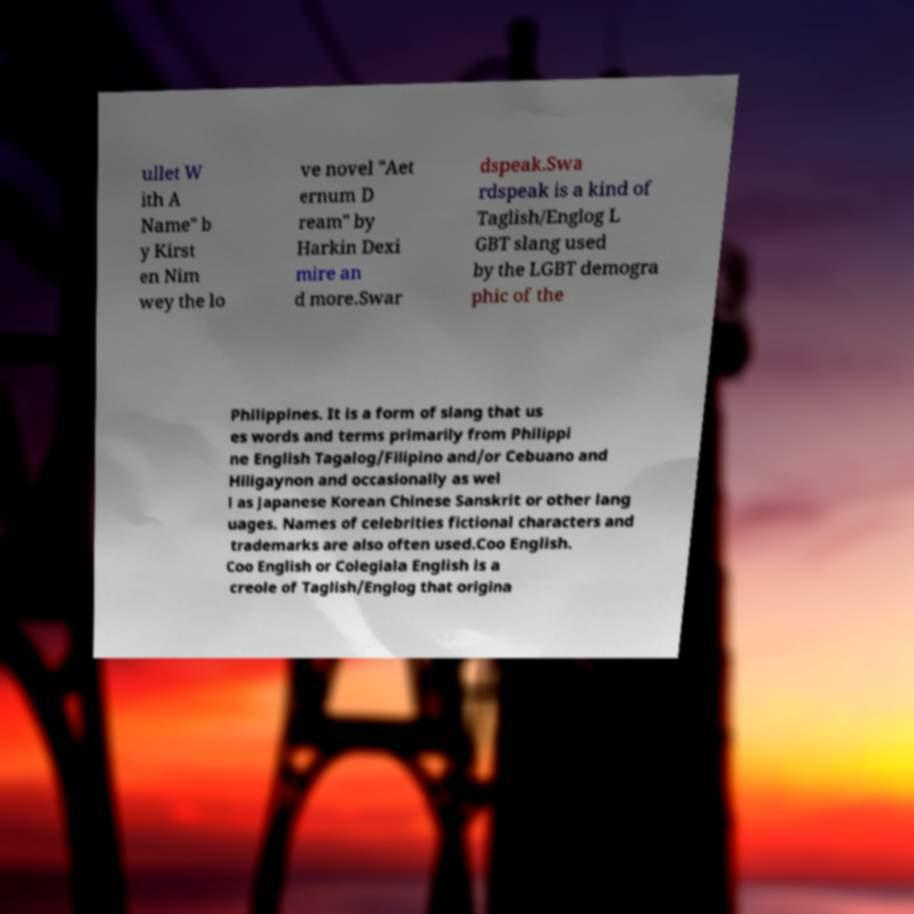I need the written content from this picture converted into text. Can you do that? ullet W ith A Name" b y Kirst en Nim wey the lo ve novel "Aet ernum D ream" by Harkin Dexi mire an d more.Swar dspeak.Swa rdspeak is a kind of Taglish/Englog L GBT slang used by the LGBT demogra phic of the Philippines. It is a form of slang that us es words and terms primarily from Philippi ne English Tagalog/Filipino and/or Cebuano and Hiligaynon and occasionally as wel l as Japanese Korean Chinese Sanskrit or other lang uages. Names of celebrities fictional characters and trademarks are also often used.Coo English. Coo English or Colegiala English is a creole of Taglish/Englog that origina 